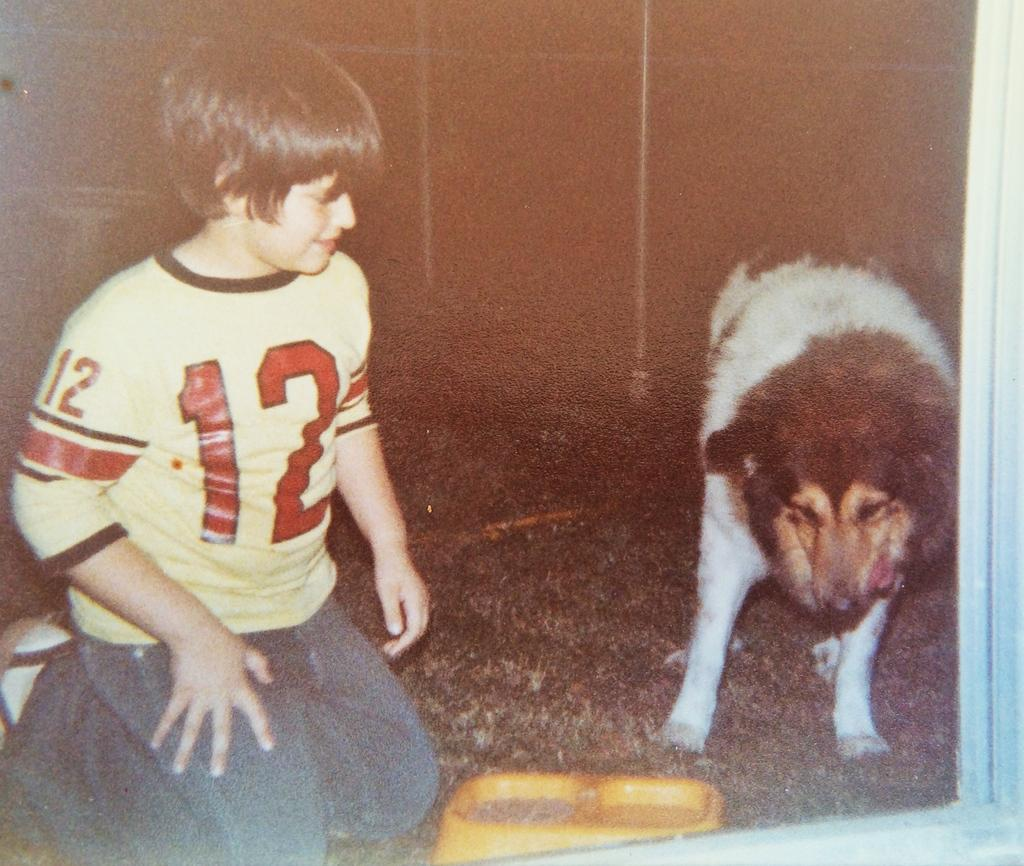What is the main subject of the image? There is a boy in the image. What is the boy doing in the image? The boy is sitting and smiling. What is the boy wearing in the image? The boy is wearing a yellow t-shirt. Are there any animals in the image? Yes, there is a dog in the image. Where is the dog located in the image? The dog is on the ground. What else can be seen in the image? There is a plate in the image. How many thumbs does the boy have in the image? The image does not show the boy's thumbs, so it cannot be determined from the image. What is the boy thinking about in the image? The image does not provide any information about the boy's thoughts or mental state. 